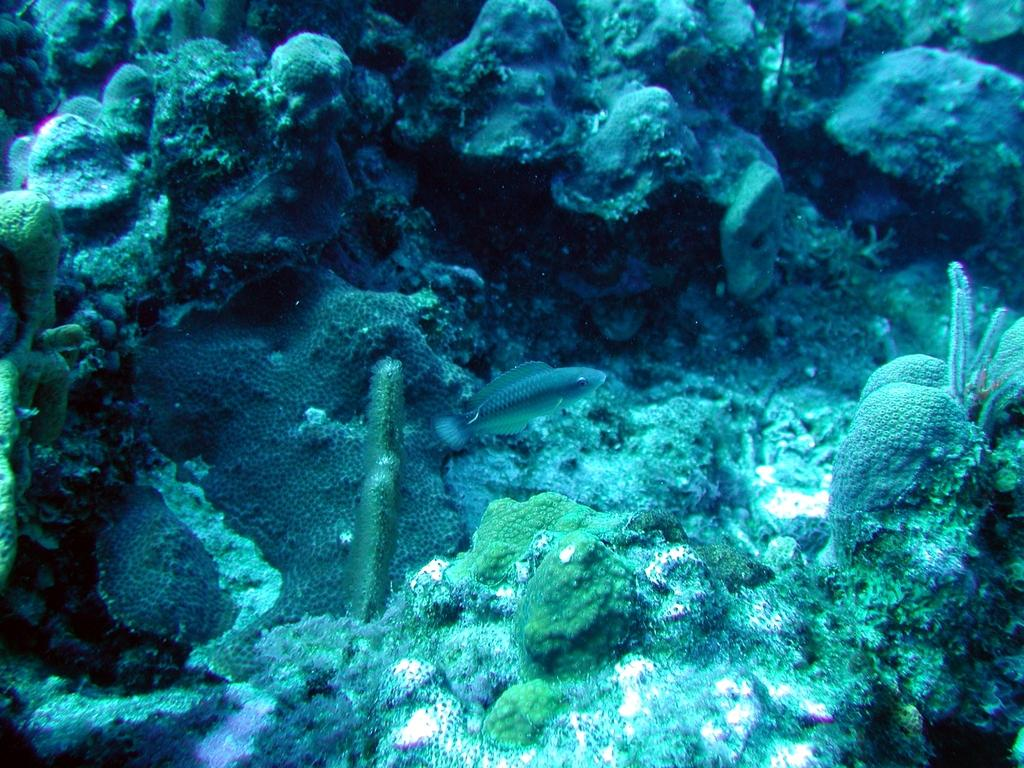What is the setting of the image? The image depicts the deep inside of the sea. What type of geological formations can be seen in the image? There are water rocks in the image. Are there any living organisms visible in the image? Yes, there are plants and fishes in the image. What other objects can be seen in the image? There are stones in the image. Can you tell me how many baseballs are floating among the plants in the image? There are no baseballs present in the image; it depicts the deep inside of the sea with water rocks, plants, stones, and fishes. 